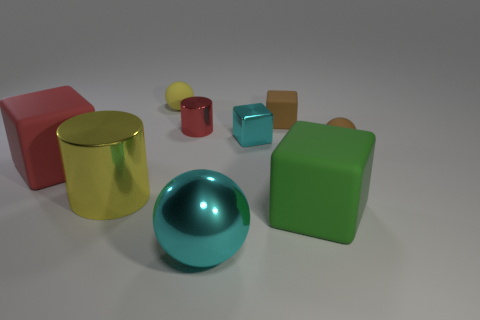Subtract all tiny spheres. How many spheres are left? 1 Subtract all green blocks. How many blocks are left? 3 Subtract all balls. How many objects are left? 6 Subtract all balls. Subtract all tiny metal blocks. How many objects are left? 5 Add 7 tiny brown spheres. How many tiny brown spheres are left? 8 Add 6 metallic objects. How many metallic objects exist? 10 Subtract 0 cyan cylinders. How many objects are left? 9 Subtract all yellow cylinders. Subtract all blue balls. How many cylinders are left? 1 